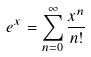<formula> <loc_0><loc_0><loc_500><loc_500>e ^ { x } = \sum _ { n = 0 } ^ { \infty } \frac { x ^ { n } } { n ! }</formula> 